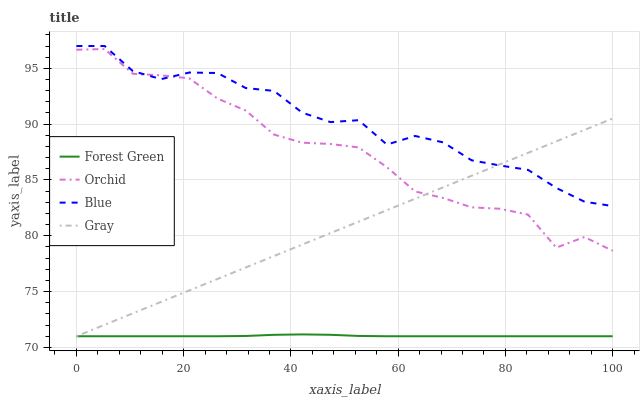Does Forest Green have the minimum area under the curve?
Answer yes or no. Yes. Does Blue have the maximum area under the curve?
Answer yes or no. Yes. Does Gray have the minimum area under the curve?
Answer yes or no. No. Does Gray have the maximum area under the curve?
Answer yes or no. No. Is Gray the smoothest?
Answer yes or no. Yes. Is Orchid the roughest?
Answer yes or no. Yes. Is Forest Green the smoothest?
Answer yes or no. No. Is Forest Green the roughest?
Answer yes or no. No. Does Gray have the lowest value?
Answer yes or no. Yes. Does Orchid have the lowest value?
Answer yes or no. No. Does Blue have the highest value?
Answer yes or no. Yes. Does Gray have the highest value?
Answer yes or no. No. Is Forest Green less than Orchid?
Answer yes or no. Yes. Is Orchid greater than Forest Green?
Answer yes or no. Yes. Does Blue intersect Gray?
Answer yes or no. Yes. Is Blue less than Gray?
Answer yes or no. No. Is Blue greater than Gray?
Answer yes or no. No. Does Forest Green intersect Orchid?
Answer yes or no. No. 